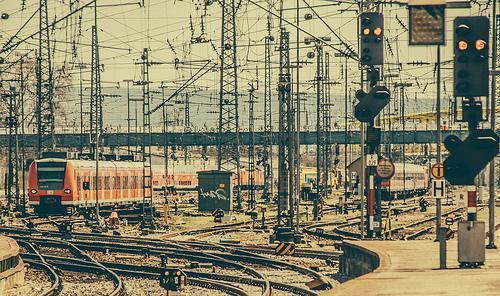How many trains are there?
Give a very brief answer. 1. 